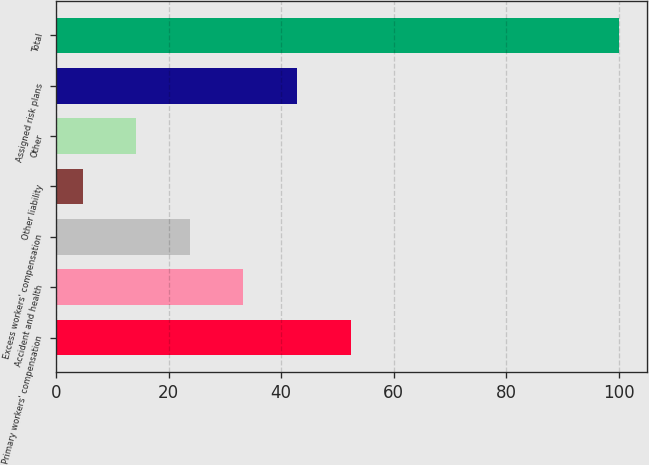Convert chart. <chart><loc_0><loc_0><loc_500><loc_500><bar_chart><fcel>Primary workers' compensation<fcel>Accident and health<fcel>Excess workers' compensation<fcel>Other liability<fcel>Other<fcel>Assigned risk plans<fcel>Total<nl><fcel>52.35<fcel>33.29<fcel>23.76<fcel>4.7<fcel>14.23<fcel>42.82<fcel>100<nl></chart> 